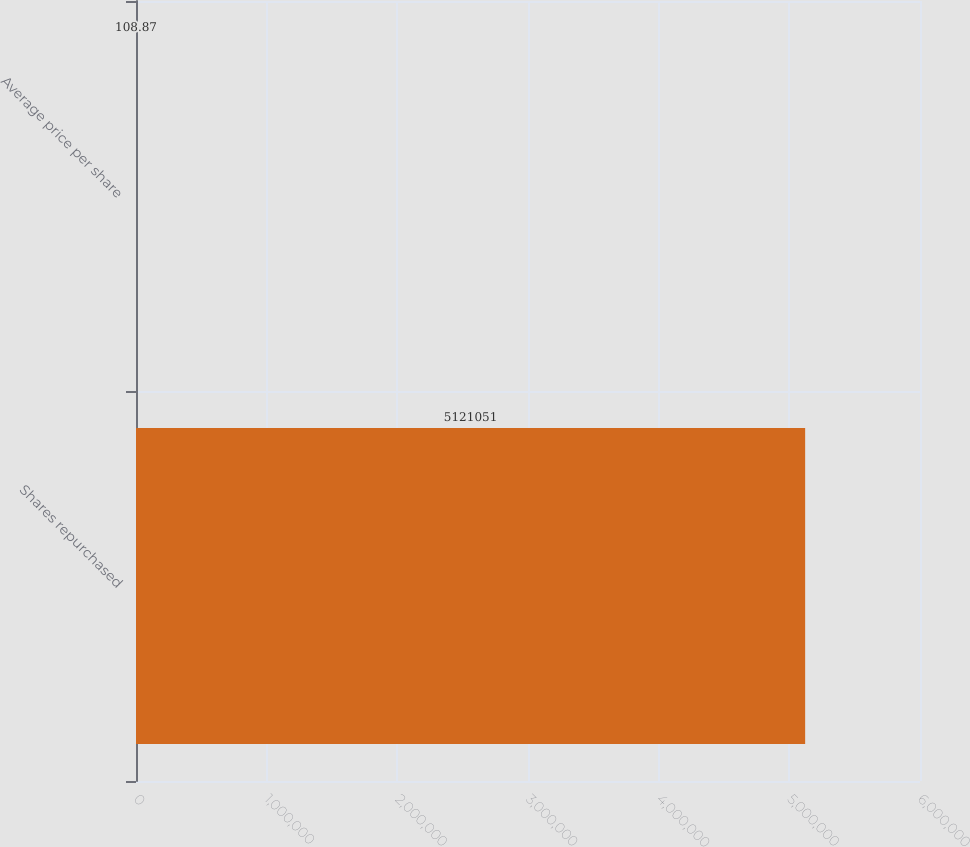<chart> <loc_0><loc_0><loc_500><loc_500><bar_chart><fcel>Shares repurchased<fcel>Average price per share<nl><fcel>5.12105e+06<fcel>108.87<nl></chart> 